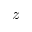Convert formula to latex. <formula><loc_0><loc_0><loc_500><loc_500>z</formula> 